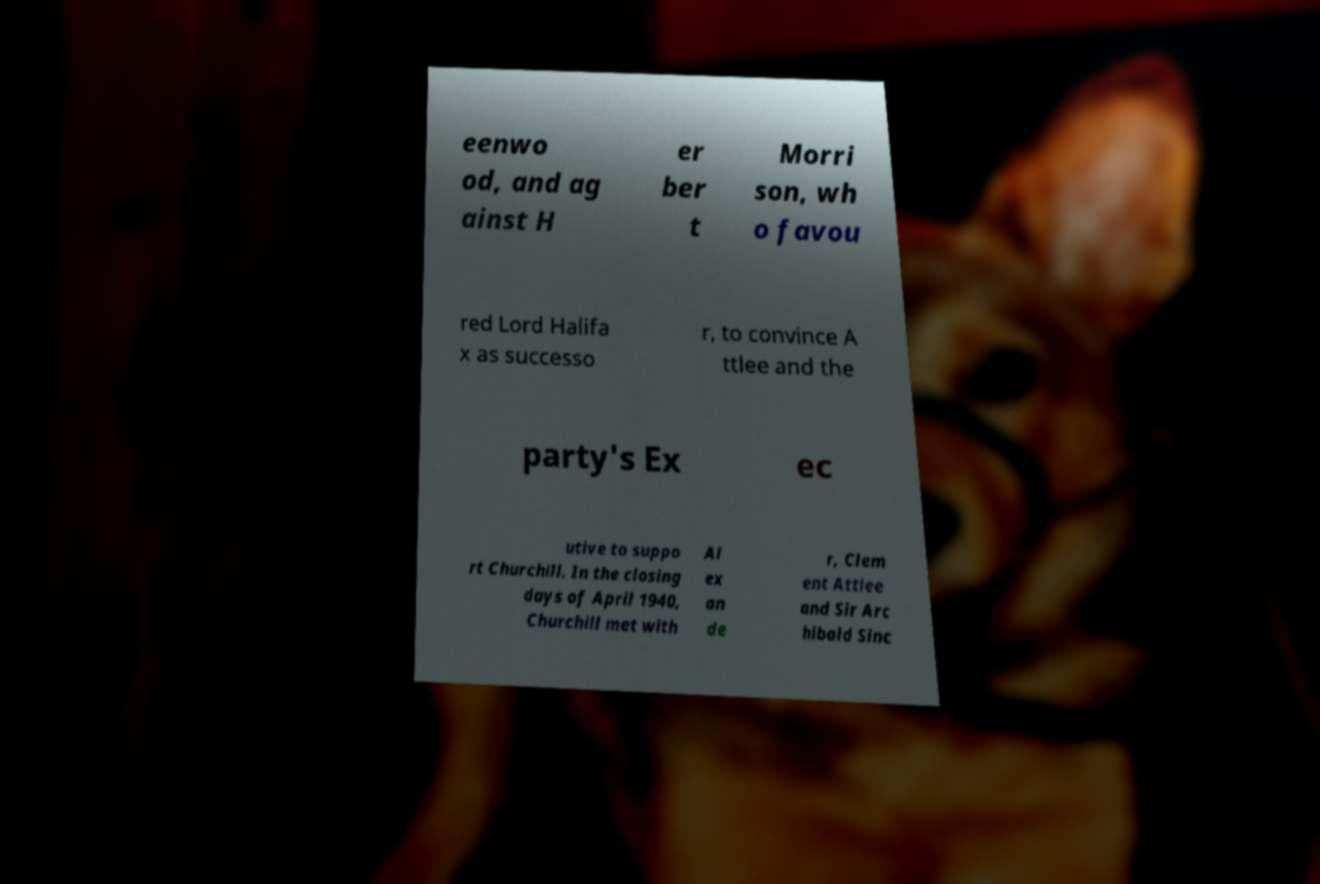I need the written content from this picture converted into text. Can you do that? eenwo od, and ag ainst H er ber t Morri son, wh o favou red Lord Halifa x as successo r, to convince A ttlee and the party's Ex ec utive to suppo rt Churchill. In the closing days of April 1940, Churchill met with Al ex an de r, Clem ent Attlee and Sir Arc hibald Sinc 